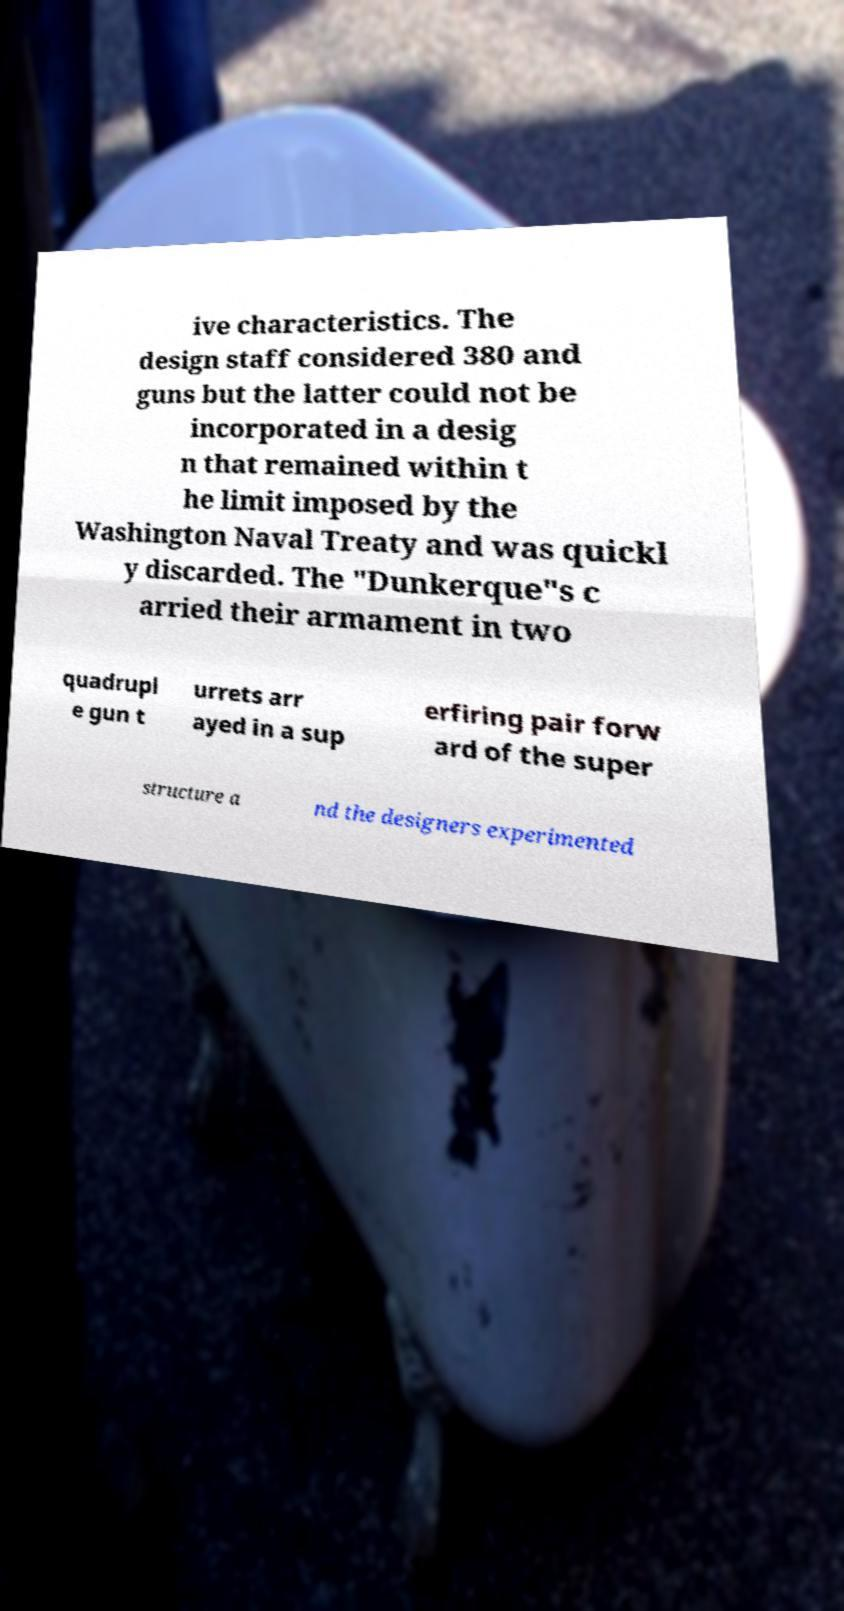Can you read and provide the text displayed in the image?This photo seems to have some interesting text. Can you extract and type it out for me? ive characteristics. The design staff considered 380 and guns but the latter could not be incorporated in a desig n that remained within t he limit imposed by the Washington Naval Treaty and was quickl y discarded. The "Dunkerque"s c arried their armament in two quadrupl e gun t urrets arr ayed in a sup erfiring pair forw ard of the super structure a nd the designers experimented 